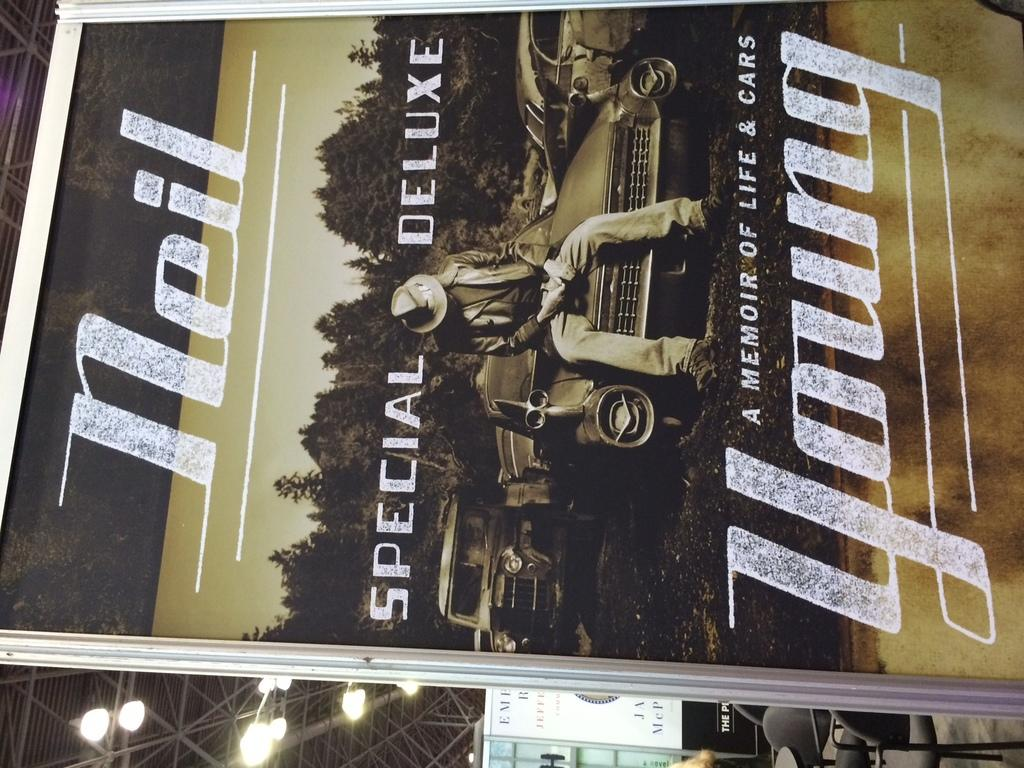What is present in the image that contains text or graphics? There is a poster in the image. What word can be seen on the poster? The word "YOUNG" is printed on the poster. What type of mouth is depicted on the poster? There is no mouth depicted on the poster; it only contains the word "YOUNG." 